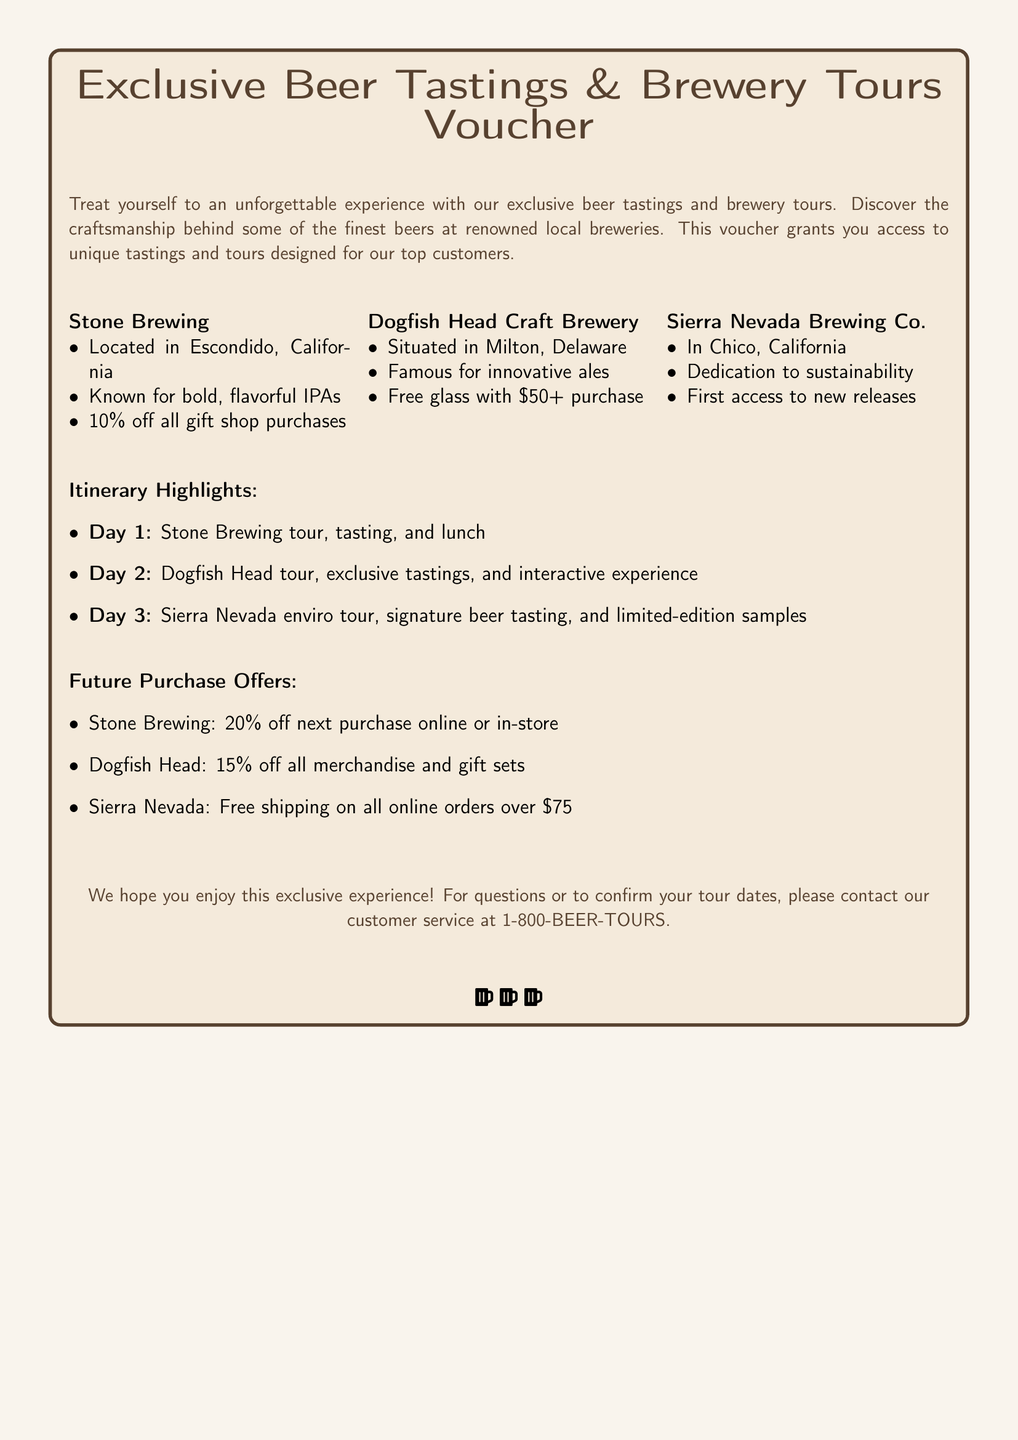What is the title of the voucher? The title provides the main focus of the document, which is promoting exclusive experiences related to beer tastings and tours.
Answer: Exclusive Beer Tastings & Brewery Tours Voucher Which brewery is located in Milton, Delaware? This question asks for the specific location of a particular brewery mentioned in the document.
Answer: Dogfish Head Craft Brewery What discount do you receive on purchases at Stone Brewing? The document outlines specific promotions for each participating brewery, including discounts on purchases.
Answer: 10% off What is the first day of the itinerary? This question requires the reader to identify the activities scheduled for the first day according to the itinerary highlights.
Answer: Day 1: Stone Brewing tour, tasting, and lunch How much off do you get on your next purchase at Stone Brewing? The document includes offers for future purchases, specifically at each brewery listed.
Answer: 20% off What type of experience does the voucher grant access to? This question focuses on the nature of the experience provided by the voucher, as summarized in the introductory section.
Answer: Unique tastings and tours Which brewery offers a free glass with a purchase of $50 or more? This question asks for the specific offer associated with one of the breweries mentioned in the document.
Answer: Dogfish Head Craft Brewery What is the contact number for customer service regarding tour dates? The document concludes with contact information for any inquiries, making this question relevant to customer service details.
Answer: 1-800-BEER-TOURS 